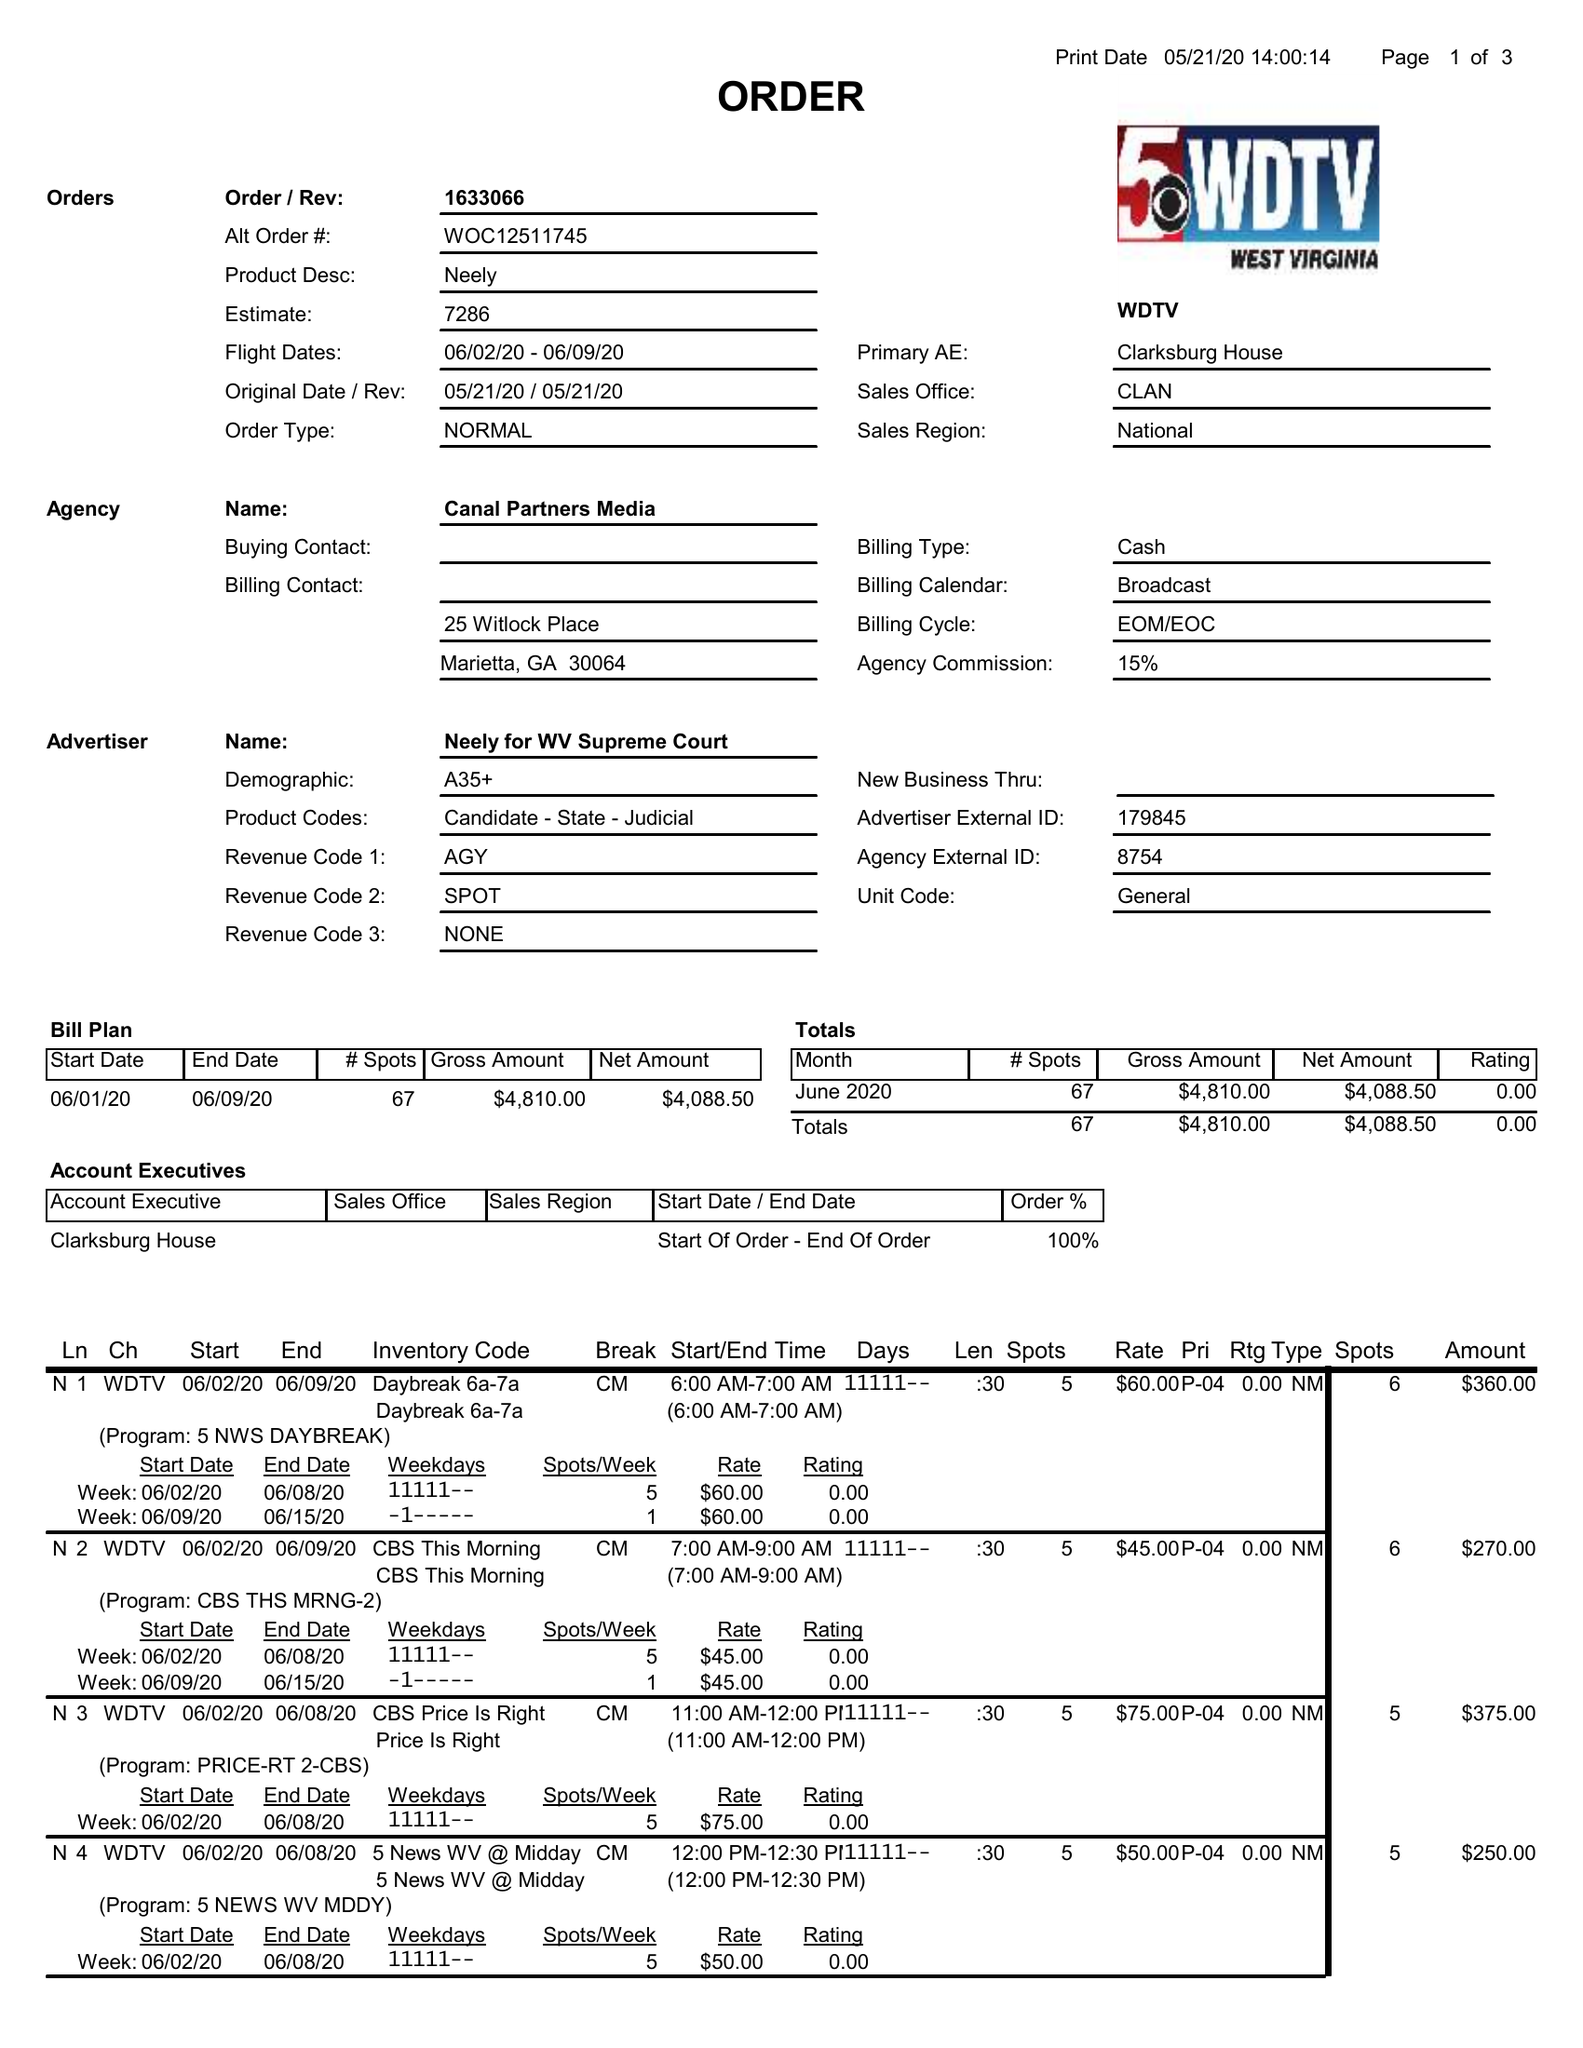What is the value for the flight_from?
Answer the question using a single word or phrase. 06/02/20 